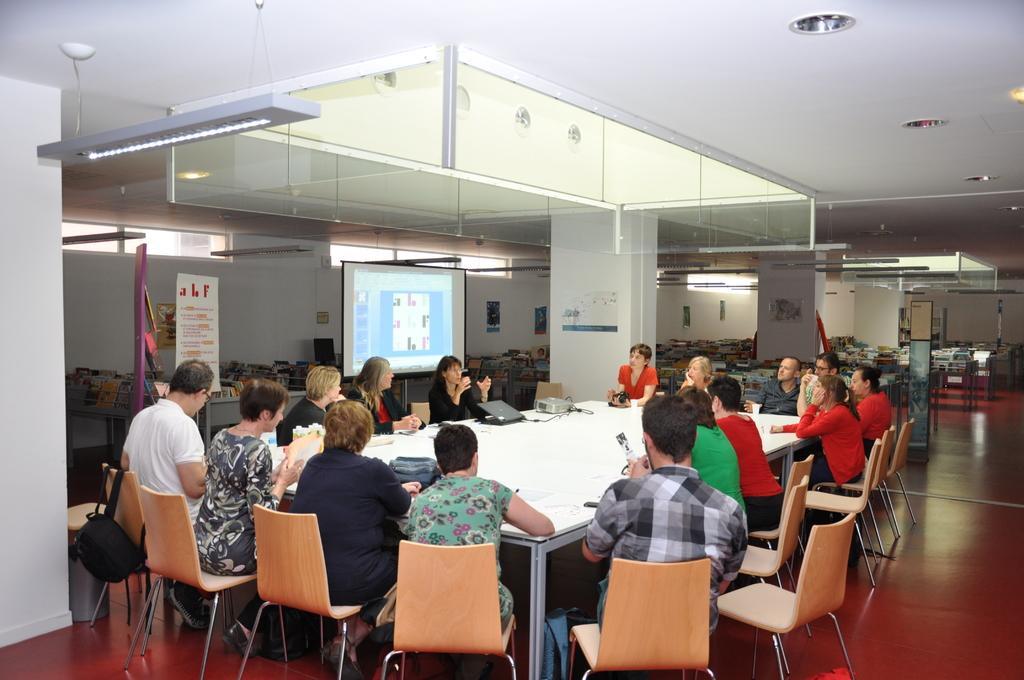Can you describe this image briefly? In the picture it's a hall with group of people sitting on chair around the table. The table has laptop,projector and bag on it. The ceiling has lights and the floor is wooden sheet color and there is flex over to the left side of the room. There are several photographs on the wall. 